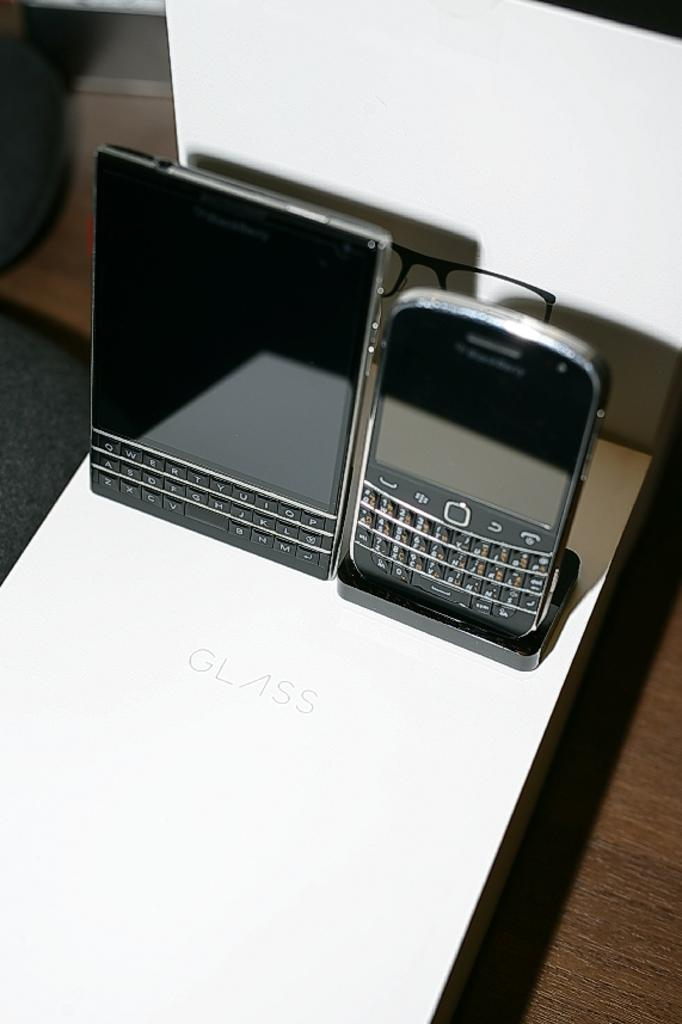How many mobiles can be seen in the image? There are two mobiles in the image. What is the color of the object with text in the image? The object with text is white. What material is the object in the bottom right of the image made of? The object in the bottom right of the image is made of wood. What is the position of the white object with text in relation to the mobiles? The white object with text is behind the mobiles. What type of cast is performing in the competition in the image? There is no cast or competition present in the image. What show is being advertised on the white object with text? The image does not provide information about any show being advertised on the white object with text. 